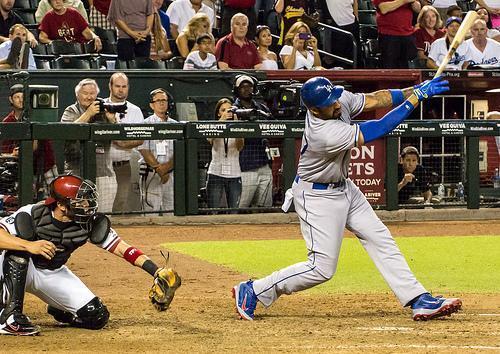How many shoes are shown?
Give a very brief answer. 2. How many fingers are visible on the batter's right hand?
Give a very brief answer. 4. How many cameramen are in the backround?
Give a very brief answer. 4. 